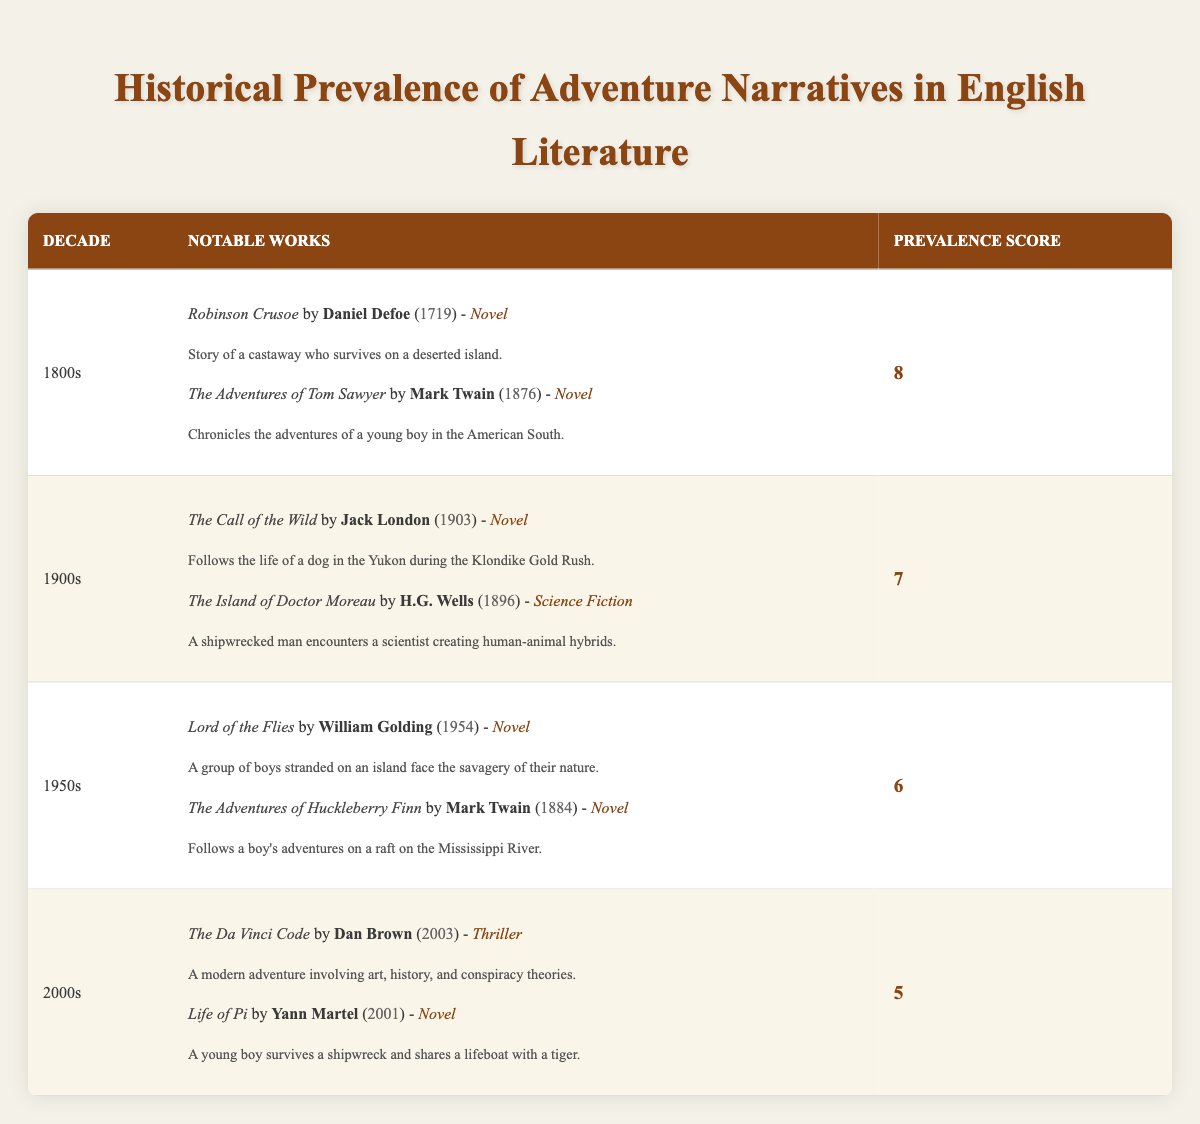What notable works were published in the 1800s? In the 1800s, the notable works listed are "Robinson Crusoe" by Daniel Defoe and "The Adventures of Tom Sawyer" by Mark Twain.
Answer: "Robinson Crusoe" and "The Adventures of Tom Sawyer" Which decade had the highest prevalence score for adventure narratives? The highest prevalence score is 8, which belongs to the decade of the 1800s.
Answer: 1800s How many notable works are listed for the 1900s? The table shows that 2 notable works are listed for the 1900s: "The Call of the Wild" and "The Island of Doctor Moreau."
Answer: 2 What is the average prevalence score of the decades listed? The prevalence scores are 8, 7, 6, and 5, which sum to 26. There are 4 decades, so the average prevalence score is 26 divided by 4, which equals 6.5.
Answer: 6.5 Is "Life of Pi" listed as an adventure narrative from the 1950s? No, "Life of Pi" is not listed for the 1950s; it was published in the 2000s.
Answer: No Which author appears most frequently in the table? The author Mark Twain appears twice in the table, contributing to both the 1800s with "The Adventures of Tom Sawyer" and the 1950s with "The Adventures of Huckleberry Finn."
Answer: Mark Twain What is the difference in prevalence score between the 1800s and the 2000s? The prevalence score for the 1800s is 8, and for the 2000s, it is 5. Therefore, the difference is 8 minus 5, which equals 3.
Answer: 3 What genre is "The Island of Doctor Moreau" and in what year was it published? "The Island of Doctor Moreau" is classified as science fiction, and it was published in 1896.
Answer: Science Fiction, 1896 